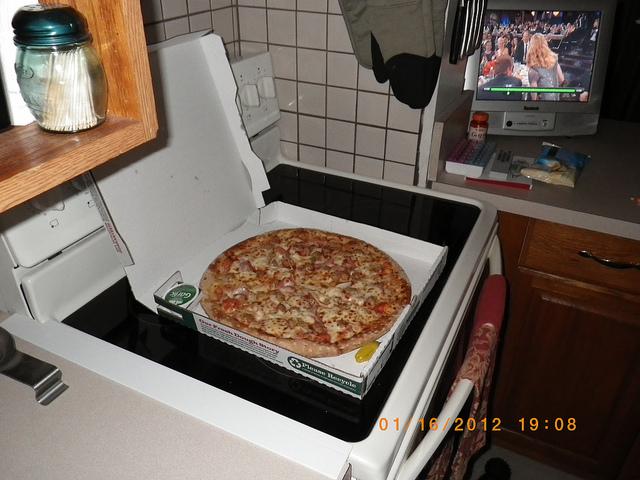Is the pizza hot?
Quick response, please. Yes. What is dangerous about this scene?
Be succinct. Box on stove. Are there chairs or benches to sit on?
Quick response, please. No. Will the pizza fry out in an open box?
Be succinct. No. How many pizzas?
Quick response, please. 1. Is the TV on?
Concise answer only. Yes. Can you spot a knife?
Keep it brief. No. What kind of food is in the boxes?
Write a very short answer. Pizza. Is this a fattening meal?
Write a very short answer. Yes. What is inside the box?
Quick response, please. Pizza. Has anyone had a slice of pizza yet?
Give a very brief answer. No. 